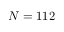<formula> <loc_0><loc_0><loc_500><loc_500>N = 1 1 2</formula> 